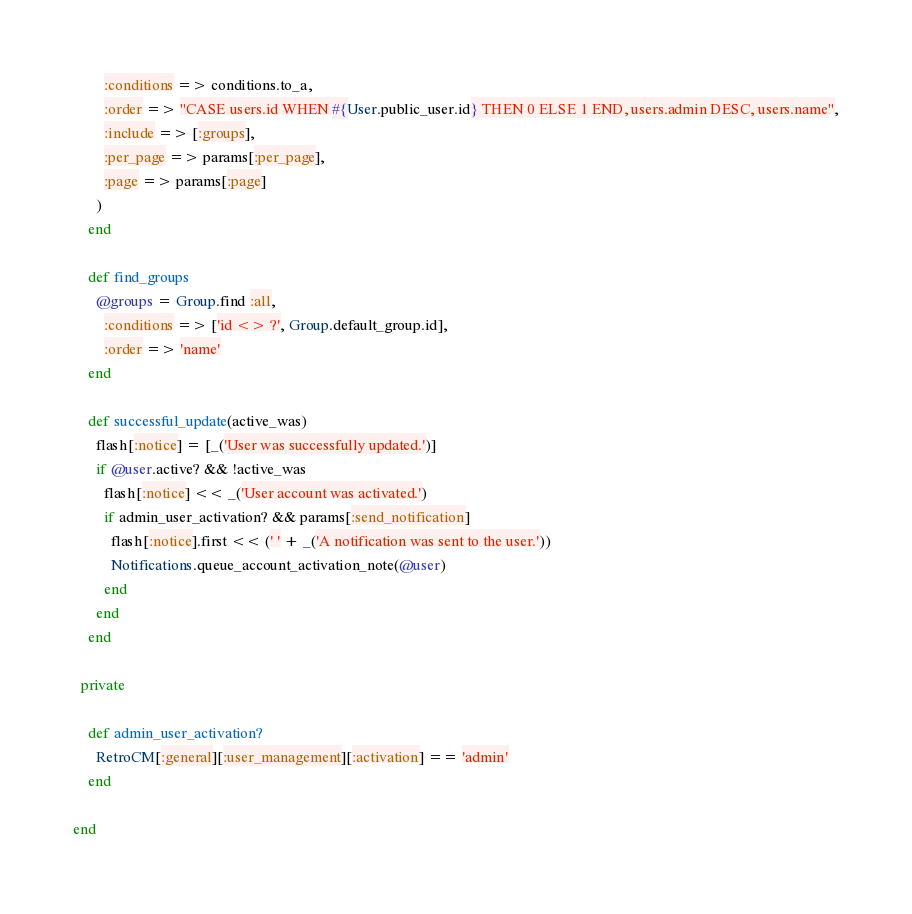<code> <loc_0><loc_0><loc_500><loc_500><_Ruby_>        :conditions => conditions.to_a,
        :order => "CASE users.id WHEN #{User.public_user.id} THEN 0 ELSE 1 END, users.admin DESC, users.name",
        :include => [:groups],
        :per_page => params[:per_page],
        :page => params[:page]
      )
    end
    
    def find_groups
      @groups = Group.find :all,
        :conditions => ['id <> ?', Group.default_group.id],
        :order => 'name'
    end
  
    def successful_update(active_was)
      flash[:notice] = [_('User was successfully updated.')]
      if @user.active? && !active_was
        flash[:notice] << _('User account was activated.')
        if admin_user_activation? && params[:send_notification]
          flash[:notice].first << (' ' + _('A notification was sent to the user.'))
          Notifications.queue_account_activation_note(@user)
        end
      end      
    end

  private

    def admin_user_activation?
      RetroCM[:general][:user_management][:activation] == 'admin'      
    end
  
end
</code> 